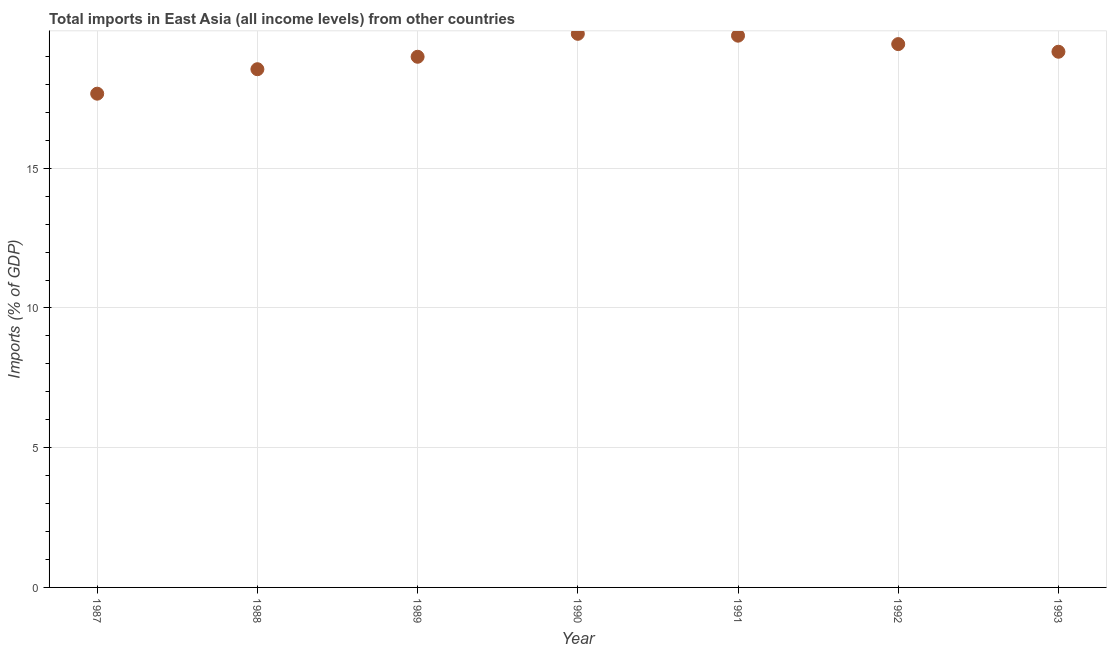What is the total imports in 1987?
Ensure brevity in your answer.  17.67. Across all years, what is the maximum total imports?
Offer a very short reply. 19.81. Across all years, what is the minimum total imports?
Ensure brevity in your answer.  17.67. In which year was the total imports maximum?
Ensure brevity in your answer.  1990. In which year was the total imports minimum?
Offer a very short reply. 1987. What is the sum of the total imports?
Keep it short and to the point. 133.37. What is the difference between the total imports in 1987 and 1988?
Give a very brief answer. -0.88. What is the average total imports per year?
Provide a short and direct response. 19.05. What is the median total imports?
Your response must be concise. 19.17. In how many years, is the total imports greater than 1 %?
Make the answer very short. 7. Do a majority of the years between 1992 and 1993 (inclusive) have total imports greater than 18 %?
Your answer should be very brief. Yes. What is the ratio of the total imports in 1990 to that in 1991?
Provide a succinct answer. 1. Is the total imports in 1989 less than that in 1990?
Provide a short and direct response. Yes. What is the difference between the highest and the second highest total imports?
Ensure brevity in your answer.  0.07. Is the sum of the total imports in 1987 and 1992 greater than the maximum total imports across all years?
Keep it short and to the point. Yes. What is the difference between the highest and the lowest total imports?
Keep it short and to the point. 2.14. In how many years, is the total imports greater than the average total imports taken over all years?
Your answer should be compact. 4. What is the difference between two consecutive major ticks on the Y-axis?
Make the answer very short. 5. What is the title of the graph?
Ensure brevity in your answer.  Total imports in East Asia (all income levels) from other countries. What is the label or title of the X-axis?
Make the answer very short. Year. What is the label or title of the Y-axis?
Make the answer very short. Imports (% of GDP). What is the Imports (% of GDP) in 1987?
Offer a terse response. 17.67. What is the Imports (% of GDP) in 1988?
Your answer should be compact. 18.54. What is the Imports (% of GDP) in 1989?
Keep it short and to the point. 18.99. What is the Imports (% of GDP) in 1990?
Your answer should be compact. 19.81. What is the Imports (% of GDP) in 1991?
Your answer should be very brief. 19.74. What is the Imports (% of GDP) in 1992?
Your answer should be very brief. 19.44. What is the Imports (% of GDP) in 1993?
Give a very brief answer. 19.17. What is the difference between the Imports (% of GDP) in 1987 and 1988?
Keep it short and to the point. -0.88. What is the difference between the Imports (% of GDP) in 1987 and 1989?
Your answer should be compact. -1.32. What is the difference between the Imports (% of GDP) in 1987 and 1990?
Make the answer very short. -2.14. What is the difference between the Imports (% of GDP) in 1987 and 1991?
Your response must be concise. -2.08. What is the difference between the Imports (% of GDP) in 1987 and 1992?
Ensure brevity in your answer.  -1.77. What is the difference between the Imports (% of GDP) in 1987 and 1993?
Your response must be concise. -1.5. What is the difference between the Imports (% of GDP) in 1988 and 1989?
Your response must be concise. -0.45. What is the difference between the Imports (% of GDP) in 1988 and 1990?
Make the answer very short. -1.27. What is the difference between the Imports (% of GDP) in 1988 and 1991?
Your answer should be compact. -1.2. What is the difference between the Imports (% of GDP) in 1988 and 1992?
Your answer should be compact. -0.9. What is the difference between the Imports (% of GDP) in 1988 and 1993?
Offer a very short reply. -0.63. What is the difference between the Imports (% of GDP) in 1989 and 1990?
Provide a succinct answer. -0.82. What is the difference between the Imports (% of GDP) in 1989 and 1991?
Your response must be concise. -0.75. What is the difference between the Imports (% of GDP) in 1989 and 1992?
Your answer should be compact. -0.45. What is the difference between the Imports (% of GDP) in 1989 and 1993?
Provide a short and direct response. -0.18. What is the difference between the Imports (% of GDP) in 1990 and 1991?
Make the answer very short. 0.07. What is the difference between the Imports (% of GDP) in 1990 and 1992?
Provide a succinct answer. 0.37. What is the difference between the Imports (% of GDP) in 1990 and 1993?
Your response must be concise. 0.64. What is the difference between the Imports (% of GDP) in 1991 and 1992?
Keep it short and to the point. 0.3. What is the difference between the Imports (% of GDP) in 1991 and 1993?
Your answer should be very brief. 0.57. What is the difference between the Imports (% of GDP) in 1992 and 1993?
Make the answer very short. 0.27. What is the ratio of the Imports (% of GDP) in 1987 to that in 1988?
Your answer should be compact. 0.95. What is the ratio of the Imports (% of GDP) in 1987 to that in 1990?
Offer a very short reply. 0.89. What is the ratio of the Imports (% of GDP) in 1987 to that in 1991?
Make the answer very short. 0.9. What is the ratio of the Imports (% of GDP) in 1987 to that in 1992?
Offer a very short reply. 0.91. What is the ratio of the Imports (% of GDP) in 1987 to that in 1993?
Make the answer very short. 0.92. What is the ratio of the Imports (% of GDP) in 1988 to that in 1989?
Make the answer very short. 0.98. What is the ratio of the Imports (% of GDP) in 1988 to that in 1990?
Offer a very short reply. 0.94. What is the ratio of the Imports (% of GDP) in 1988 to that in 1991?
Your response must be concise. 0.94. What is the ratio of the Imports (% of GDP) in 1988 to that in 1992?
Your answer should be very brief. 0.95. What is the ratio of the Imports (% of GDP) in 1988 to that in 1993?
Make the answer very short. 0.97. What is the ratio of the Imports (% of GDP) in 1989 to that in 1991?
Your answer should be compact. 0.96. What is the ratio of the Imports (% of GDP) in 1990 to that in 1991?
Your response must be concise. 1. What is the ratio of the Imports (% of GDP) in 1990 to that in 1992?
Offer a very short reply. 1.02. What is the ratio of the Imports (% of GDP) in 1990 to that in 1993?
Ensure brevity in your answer.  1.03. 